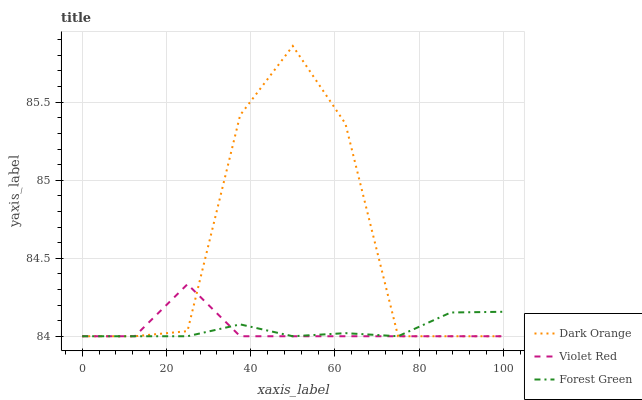Does Forest Green have the minimum area under the curve?
Answer yes or no. Yes. Does Dark Orange have the maximum area under the curve?
Answer yes or no. Yes. Does Violet Red have the minimum area under the curve?
Answer yes or no. No. Does Violet Red have the maximum area under the curve?
Answer yes or no. No. Is Forest Green the smoothest?
Answer yes or no. Yes. Is Dark Orange the roughest?
Answer yes or no. Yes. Is Violet Red the smoothest?
Answer yes or no. No. Is Violet Red the roughest?
Answer yes or no. No. Does Dark Orange have the lowest value?
Answer yes or no. Yes. Does Dark Orange have the highest value?
Answer yes or no. Yes. Does Violet Red have the highest value?
Answer yes or no. No. Does Violet Red intersect Dark Orange?
Answer yes or no. Yes. Is Violet Red less than Dark Orange?
Answer yes or no. No. Is Violet Red greater than Dark Orange?
Answer yes or no. No. 